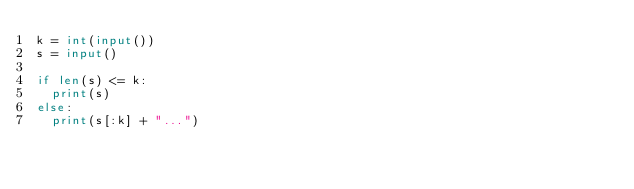<code> <loc_0><loc_0><loc_500><loc_500><_Python_>k = int(input())
s = input()

if len(s) <= k:
  print(s)
else:
  print(s[:k] + "...")
  </code> 